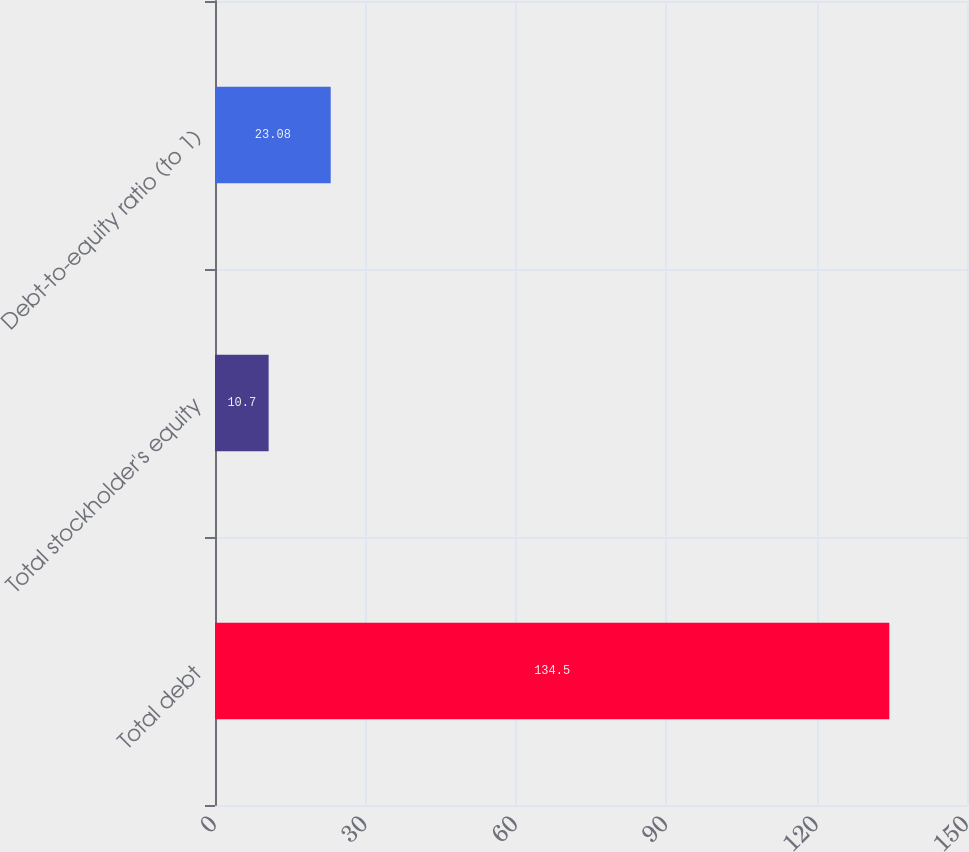Convert chart. <chart><loc_0><loc_0><loc_500><loc_500><bar_chart><fcel>Total debt<fcel>Total stockholder's equity<fcel>Debt-to-equity ratio (to 1)<nl><fcel>134.5<fcel>10.7<fcel>23.08<nl></chart> 